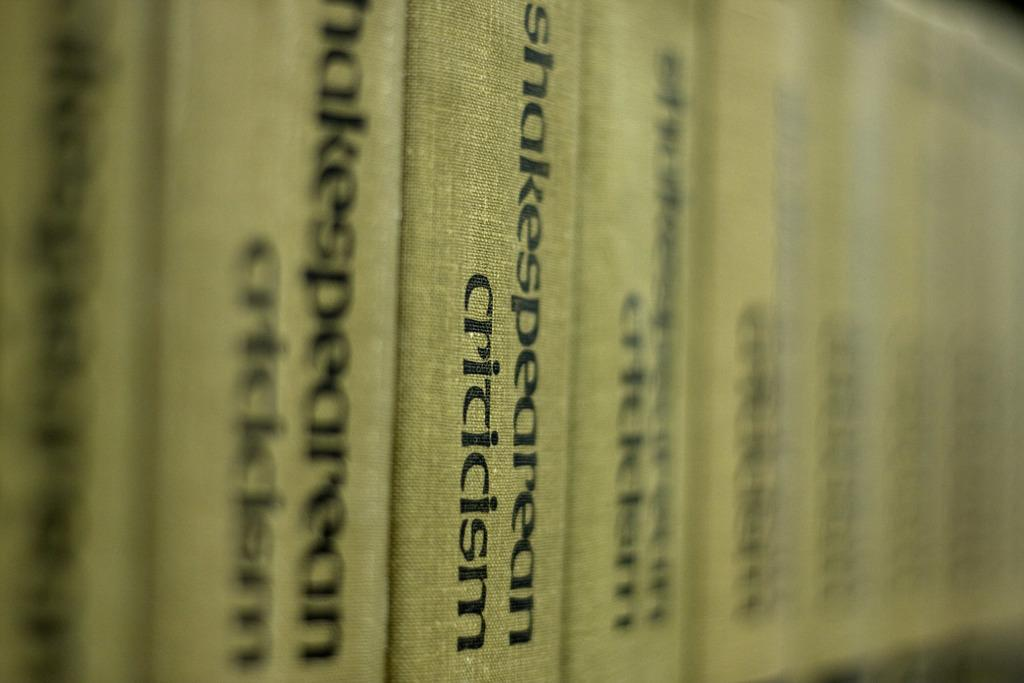<image>
Offer a succinct explanation of the picture presented. A row of black and white books that have the label Shakespearean Criticism. 